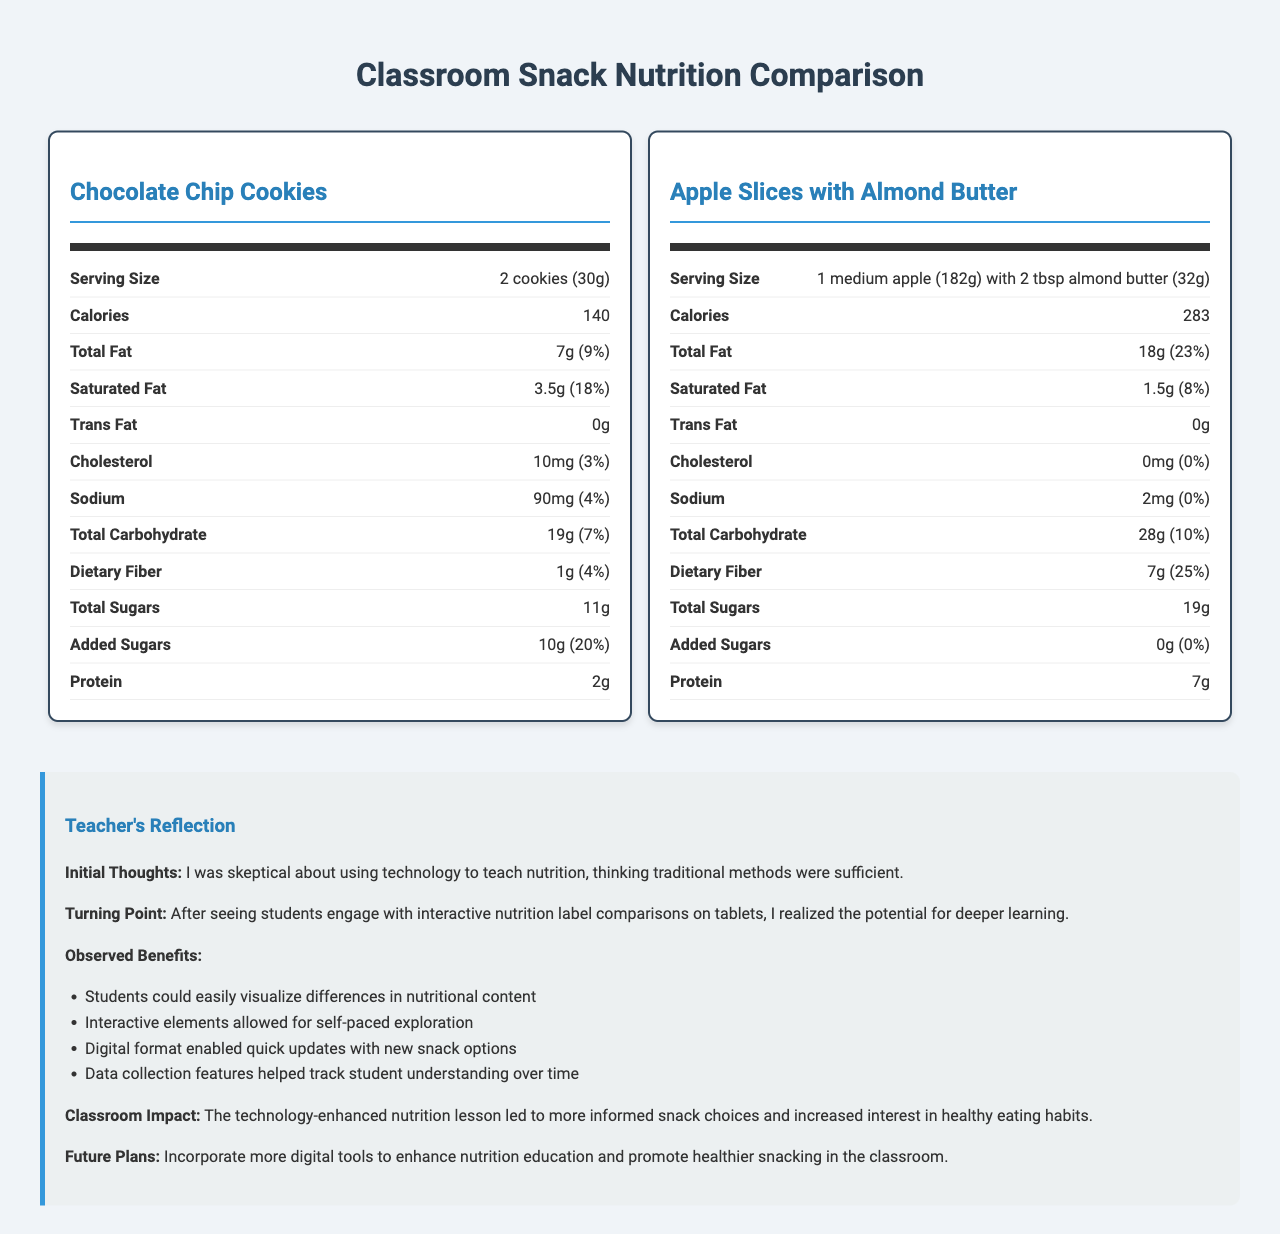what is the serving size of the healthier snack? The serving size of the healthier alternative, Apple Slices with Almond Butter, is displayed at the top of its nutrition label.
Answer: 1 medium apple (182g) with 2 tbsp almond butter (32g) which snack has more dietary fiber per serving? A. Chocolate Chip Cookies B. Apple Slices with Almond Butter C. Both have the same amount Chocolate Chip Cookies have 1g of dietary fiber per serving, while Apple Slices with Almond Butter have 7g per serving.
Answer: B does the healthier snack contain any cholesterol? According to the nutrition facts, the healthier snack (Apple Slices with Almond Butter) has 0mg of cholesterol.
Answer: No which snack has a higher percentage of daily calcium? Apple Slices with Almond Butter have 8% of the daily value for calcium, while Chocolate Chip Cookies have 0%.
Answer: Apple Slices with Almond Butter how many total sugars are in a serving of chocolate chip cookies? The total sugars for Chocolate Chip Cookies are listed as 11g per serving on the nutrition label.
Answer: 11g does the traditional snack contain added sugars? The traditional snack (Chocolate Chip Cookies) contains 10g of added sugars per serving.
Answer: Yes which snack has more calories per serving? A. Chocolate Chip Cookies B. Apple Slices with Almond Butter Chocolate Chip Cookies have 140 calories per serving, while Apple Slices with Almond Butter have 283 calories.
Answer: B what is the teacher’s initial thought on using technology to teach nutrition? The reflection section shows the teacher’s initial skepticism about the effectiveness of technology in teaching nutrition.
Answer: I was skeptical about using technology to teach nutrition, thinking traditional methods were sufficient. who could visualize differences in nutritional content more easily after engaging with interactive comparisons? According to the teacher's reflection, students could easily visualize differences in nutritional content after engaging with interactive comparisons.
Answer: Students has the teacher decided to stop using traditional methods for teaching nutrition completely? The document does not provide information about whether the teacher has completely stopped using traditional methods.
Answer: Cannot be determined summarize the document The document features a comparison of nutrition facts for two snacks and a teacher's reflection on using technology in teaching nutrition, emphasizing observed benefits and future plans.
Answer: The document compares the nutrition facts of a traditional classroom snack, Chocolate Chip Cookies, and a healthier alternative, Apple Slices with Almond Butter. It provides a detailed comparison of various nutritional values, including calories, fats, carbohydrates, and more. Additionally, the document includes a teacher's reflection on the benefits observed after incorporating technology into nutrition education. The reflection highlights increased student engagement, better visualization of nutritional differences, and improved snacking choices. The teacher plans to continue using digital tools to enhance nutrition education. 